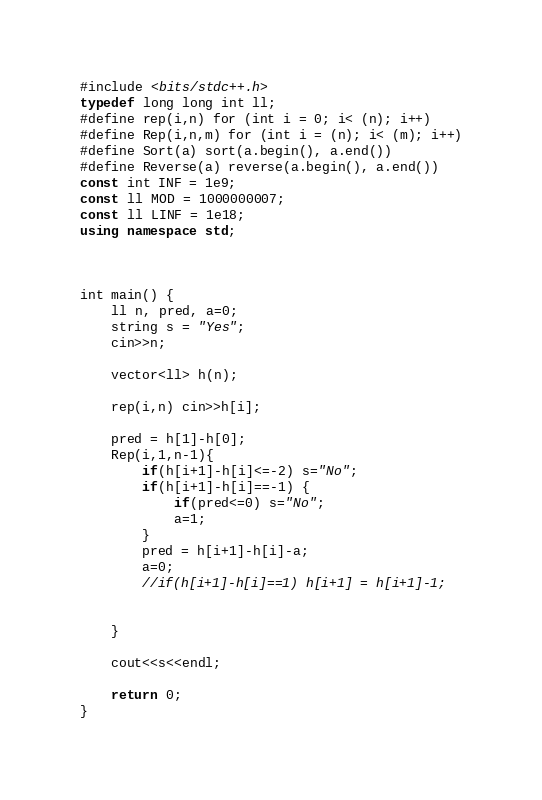Convert code to text. <code><loc_0><loc_0><loc_500><loc_500><_C++_>#include <bits/stdc++.h>
typedef long long int ll;
#define rep(i,n) for (int i = 0; i< (n); i++)
#define Rep(i,n,m) for (int i = (n); i< (m); i++)
#define Sort(a) sort(a.begin(), a.end())
#define Reverse(a) reverse(a.begin(), a.end())
const int INF = 1e9;
const ll MOD = 1000000007;
const ll LINF = 1e18;
using namespace std;



int main() {
    ll n, pred, a=0;
    string s = "Yes";
    cin>>n;
    
    vector<ll> h(n);
    
    rep(i,n) cin>>h[i];
    
    pred = h[1]-h[0];
    Rep(i,1,n-1){
        if(h[i+1]-h[i]<=-2) s="No";
        if(h[i+1]-h[i]==-1) {
            if(pred<=0) s="No";
            a=1;
        }
        pred = h[i+1]-h[i]-a;
        a=0;
        //if(h[i+1]-h[i]==1) h[i+1] = h[i+1]-1;
        
        
    }
    
    cout<<s<<endl;
    
    return 0;
}

</code> 